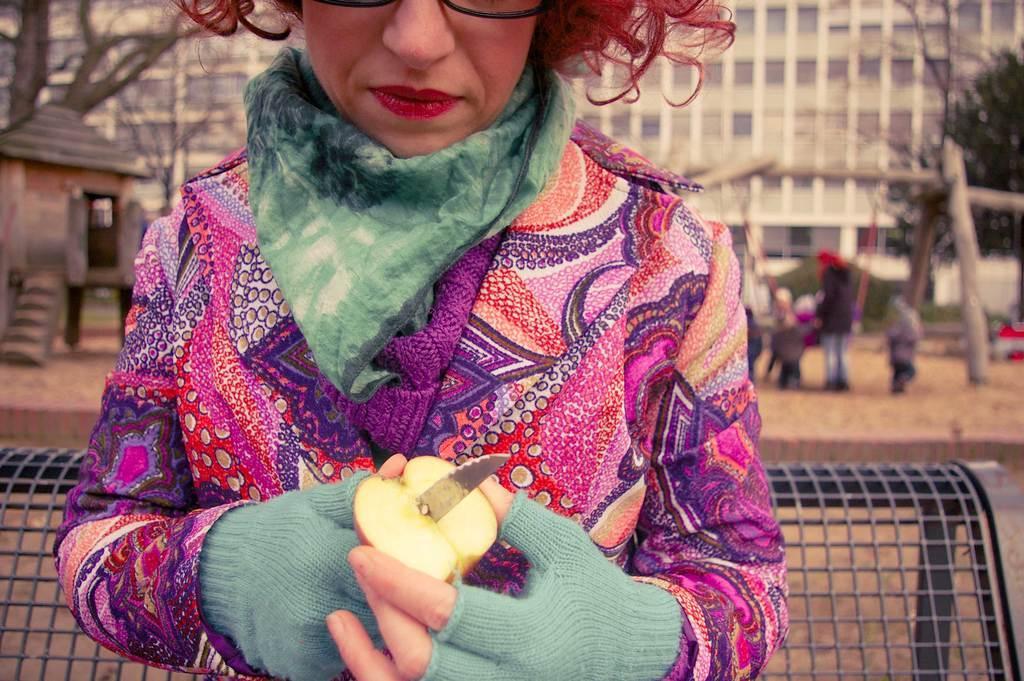In one or two sentences, can you explain what this image depicts? In this image I can see the person holding the fruit and cutting with the knife. This person is wearing the colorful dress and also the specs. To the back of this person I can see few more people standing on the ground. In the background I can see house, trees and the building. 